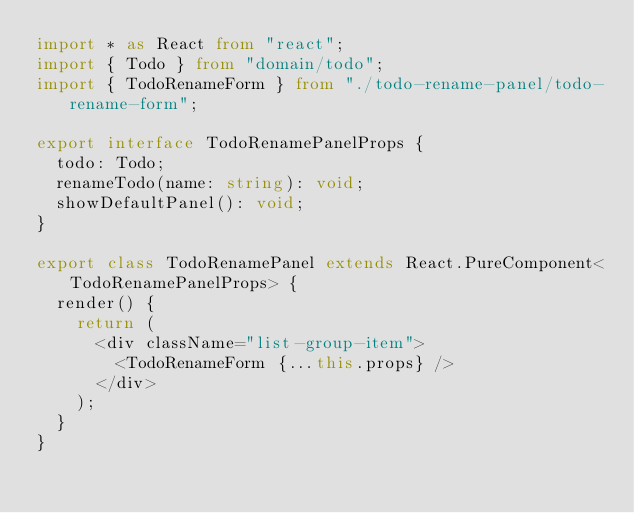Convert code to text. <code><loc_0><loc_0><loc_500><loc_500><_TypeScript_>import * as React from "react";
import { Todo } from "domain/todo";
import { TodoRenameForm } from "./todo-rename-panel/todo-rename-form";

export interface TodoRenamePanelProps {
  todo: Todo;
  renameTodo(name: string): void;
  showDefaultPanel(): void;
}

export class TodoRenamePanel extends React.PureComponent<TodoRenamePanelProps> {
  render() {
    return (
      <div className="list-group-item">
        <TodoRenameForm {...this.props} />
      </div>
    );
  }
}
</code> 